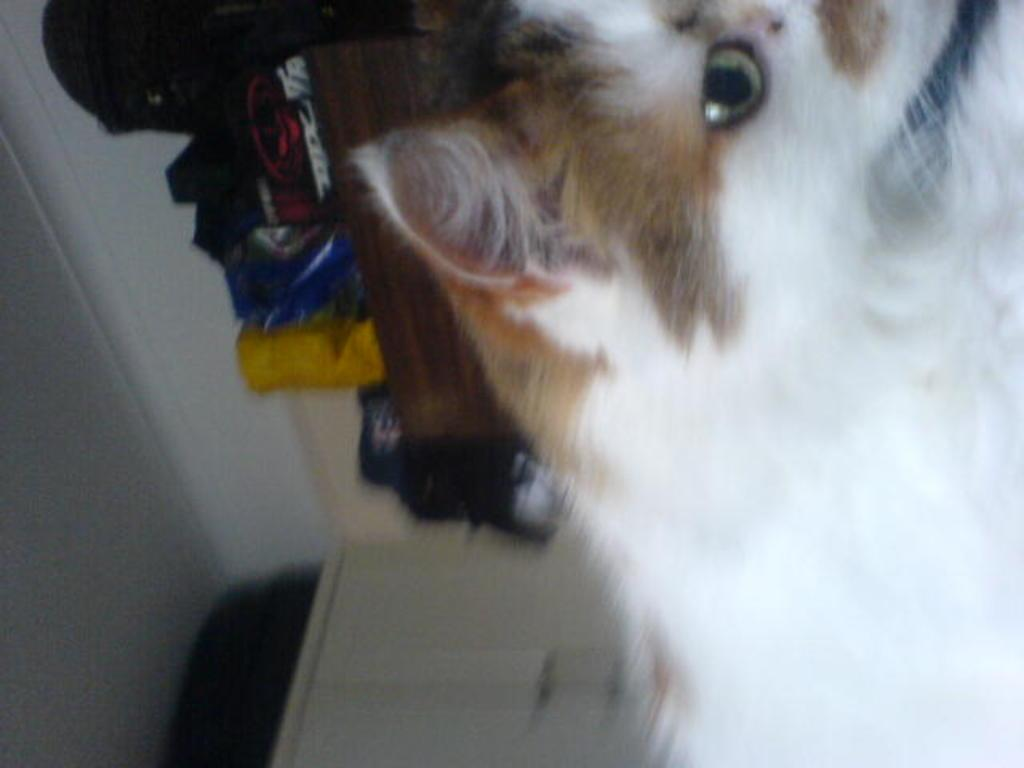What type of animal can be seen in the image? There is an animal in the image, and it has white and brown colors. What can be seen in the background of the image? There are many objects on a cupboard in the background, and there is a wall visible as well. How would you describe the appearance of the wall in the background? The wall appears blurry in the image. What type of teeth can be seen in the image? There are no teeth visible in the image; it features an animal with white and brown colors and a blurry wall in the background. 